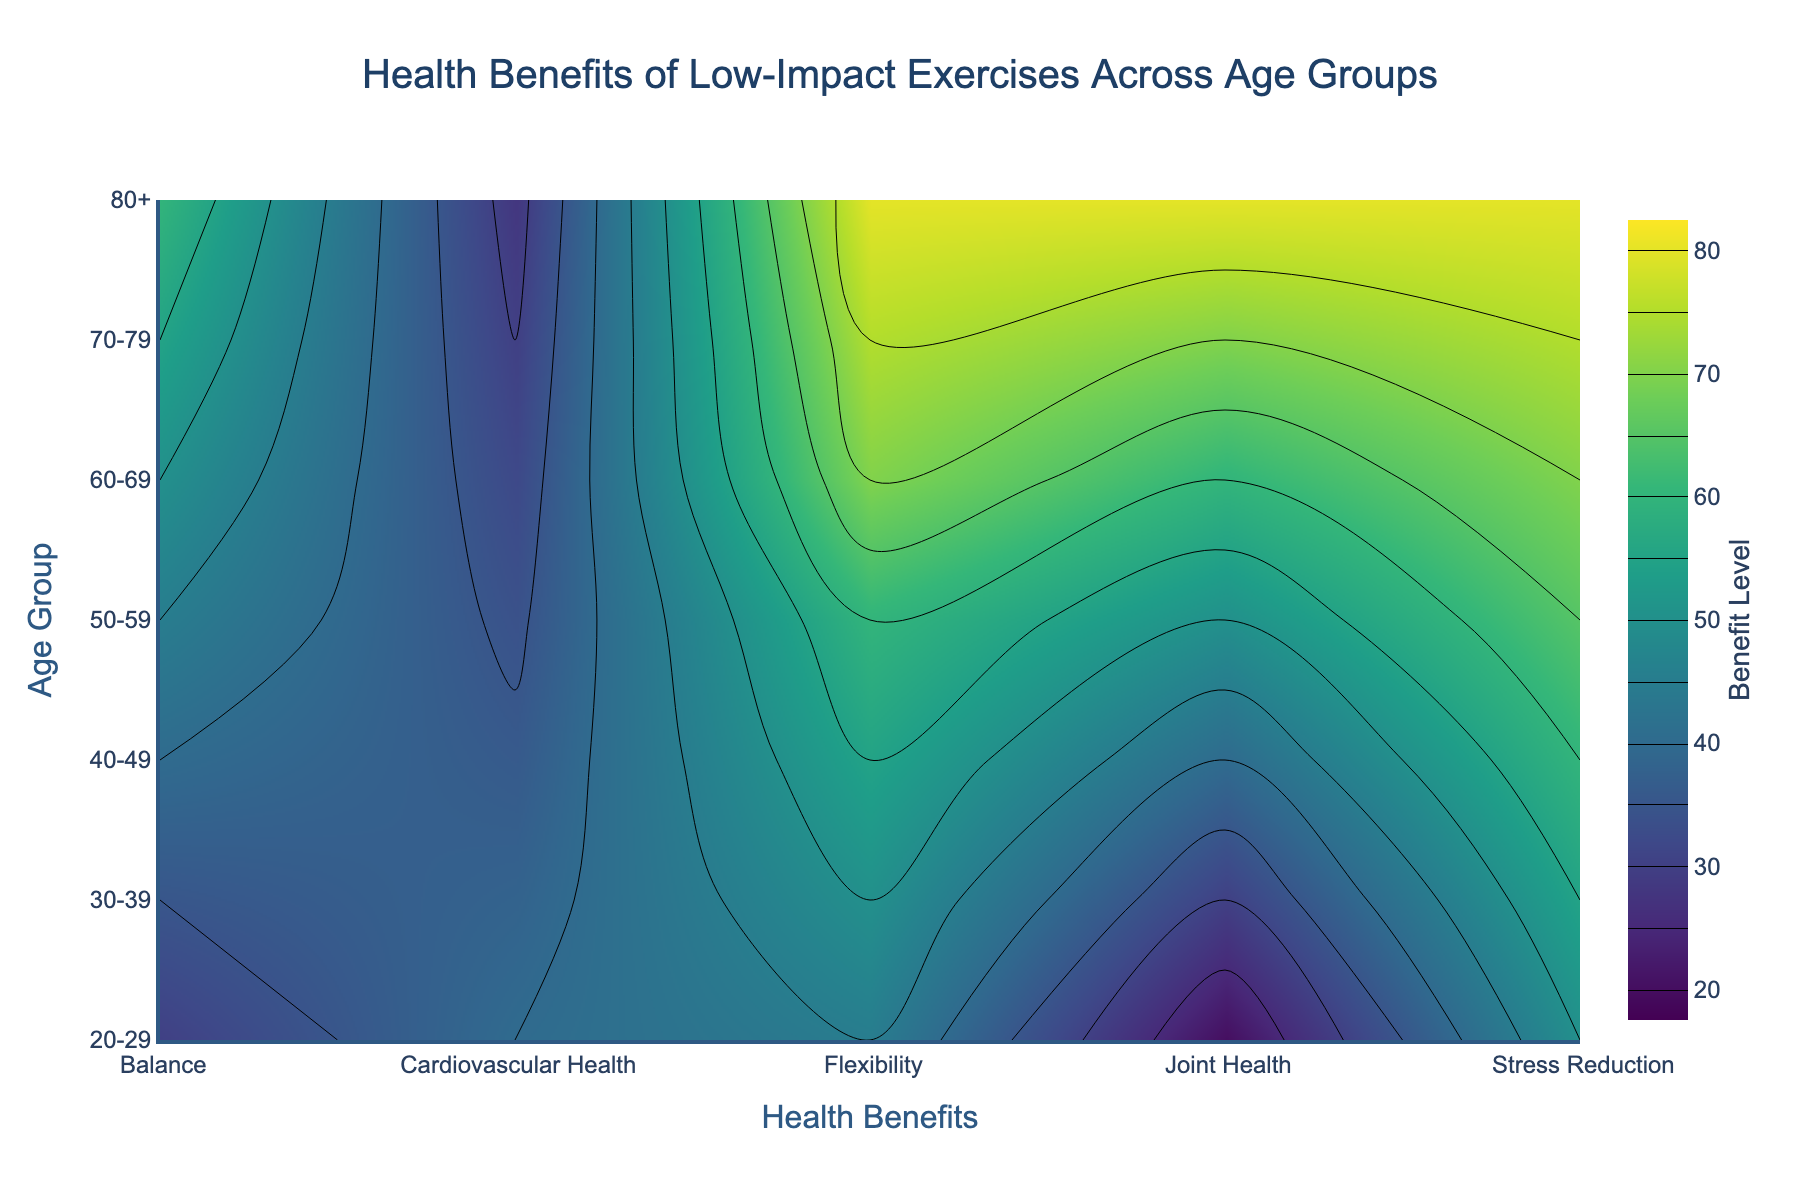Which age group benefits the most in terms of flexibility? Look at the 'Flexibility' column and find the highest value; match it to the corresponding age group on the y-axis.
Answer: 80+ Which health benefit shows the smallest improvement for the age group 30-39? For the age group '30-39', check all the health benefits and find the one with the lowest value.
Answer: Cardiovascular Health How do joint health benefits change with age? Observe the 'Joint Health' values across all age groups from youngest to oldest to see the trend.
Answer: They increase with age What's the average stress reduction benefit level across all age groups? Sum up the 'Stress Reduction' values for all age groups (50 + 55 + 60 + 65 + 70 + 75 + 80) and divide by the number of age groups (7).
Answer: 65.0 Do stress reduction benefits more or less for older groups compared to younger groups? Compare 'Stress Reduction' values of older age groups (60-69, 70-79, 80+) with younger age groups (20-29, 30-39).
Answer: More Which health benefit has the most consistent value across all age groups? Check all the health benefits and see which one has the smallest variation in values across age groups.
Answer: Cardiovascular Health At what age group do balance benefits start to surpass 50? Check the 'Balance' values for each age group and find the first one that is higher than 50.
Answer: 60-69 Between the ages of 50-59 and 70-79, which age group has a higher overall benefit level in flexibility? Compare the 'Flexibility' values for age groups 50-59 and 70-79.
Answer: 70-79 Is there any health benefit that continuously increases across all age groups? Observe the trends for all health benefits across the age groups and identify the ones that show a steady increase.
Answer: Flexibility and Joint Health 